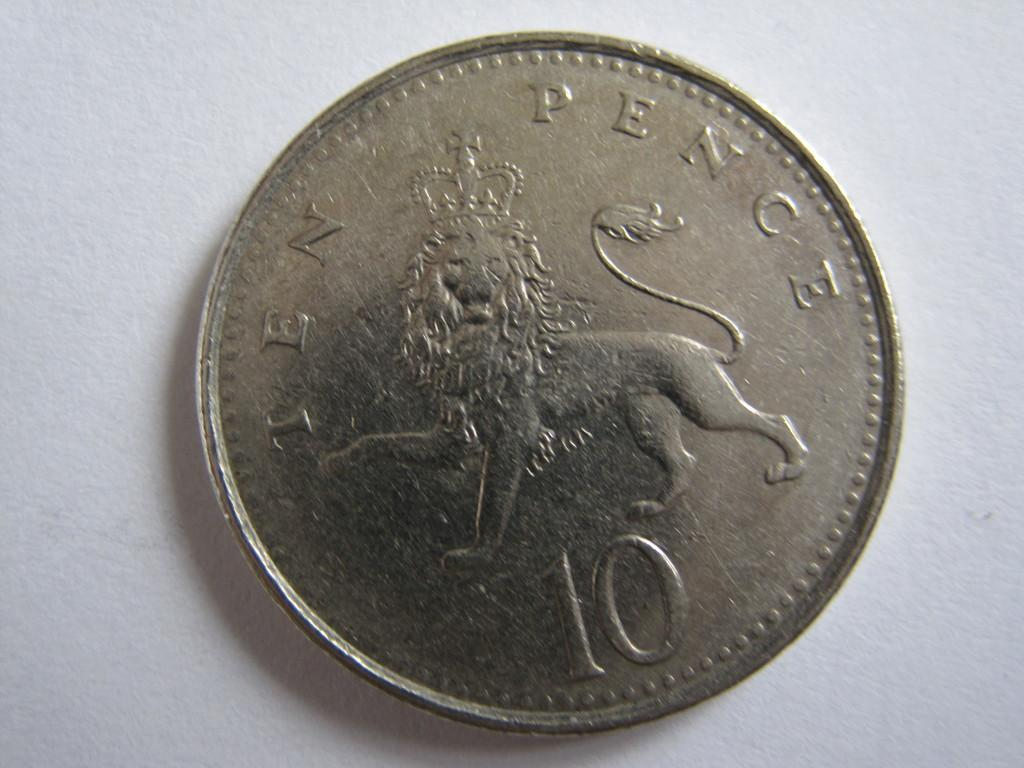<image>
Give a short and clear explanation of the subsequent image. Silver ten pence with a lion in the middle of it 